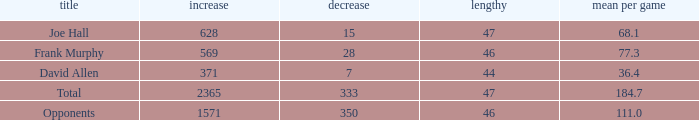How much Avg/G has a Gain smaller than 1571, and a Long smaller than 46? 1.0. 